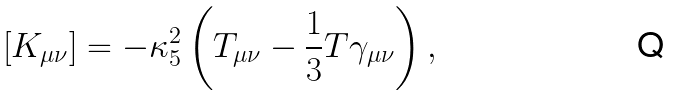Convert formula to latex. <formula><loc_0><loc_0><loc_500><loc_500>\left [ K _ { \mu \nu } \right ] = - \kappa ^ { 2 } _ { 5 } \left ( T _ { \mu \nu } - \frac { 1 } { 3 } T \gamma _ { \mu \nu } \right ) ,</formula> 